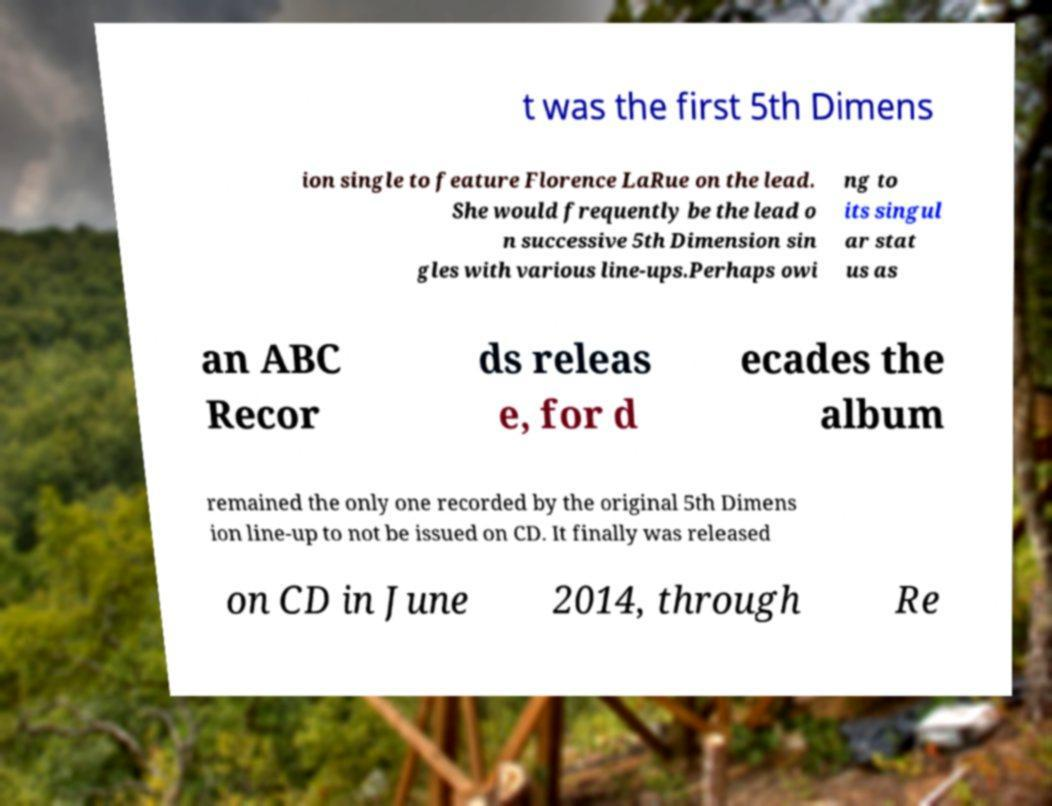Can you accurately transcribe the text from the provided image for me? t was the first 5th Dimens ion single to feature Florence LaRue on the lead. She would frequently be the lead o n successive 5th Dimension sin gles with various line-ups.Perhaps owi ng to its singul ar stat us as an ABC Recor ds releas e, for d ecades the album remained the only one recorded by the original 5th Dimens ion line-up to not be issued on CD. It finally was released on CD in June 2014, through Re 